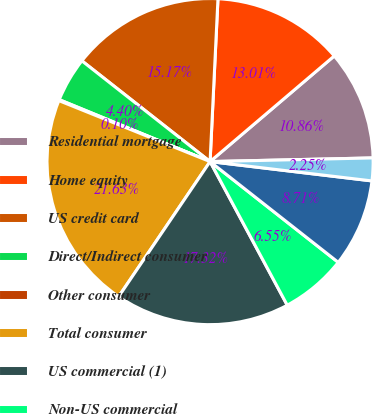Convert chart. <chart><loc_0><loc_0><loc_500><loc_500><pie_chart><fcel>Residential mortgage<fcel>Home equity<fcel>US credit card<fcel>Direct/Indirect consumer<fcel>Other consumer<fcel>Total consumer<fcel>US commercial (1)<fcel>Non-US commercial<fcel>Commercial real estate<fcel>Commercial lease financing<nl><fcel>10.86%<fcel>13.01%<fcel>15.17%<fcel>4.4%<fcel>0.1%<fcel>21.63%<fcel>17.32%<fcel>6.55%<fcel>8.71%<fcel>2.25%<nl></chart> 